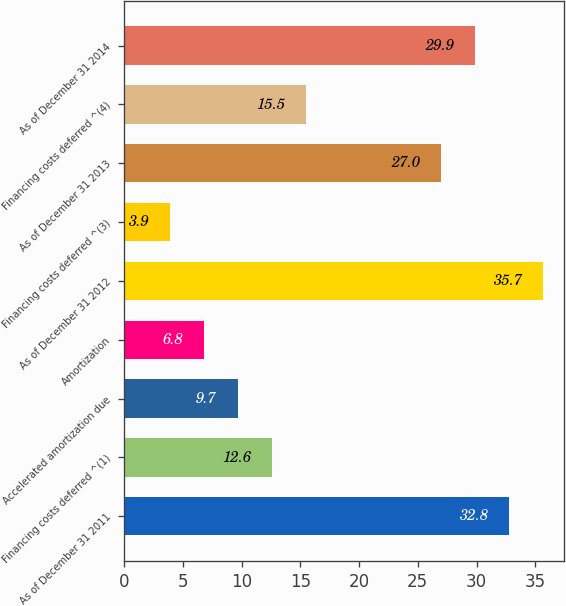Convert chart. <chart><loc_0><loc_0><loc_500><loc_500><bar_chart><fcel>As of December 31 2011<fcel>Financing costs deferred ^(1)<fcel>Accelerated amortization due<fcel>Amortization<fcel>As of December 31 2012<fcel>Financing costs deferred ^(3)<fcel>As of December 31 2013<fcel>Financing costs deferred ^(4)<fcel>As of December 31 2014<nl><fcel>32.8<fcel>12.6<fcel>9.7<fcel>6.8<fcel>35.7<fcel>3.9<fcel>27<fcel>15.5<fcel>29.9<nl></chart> 